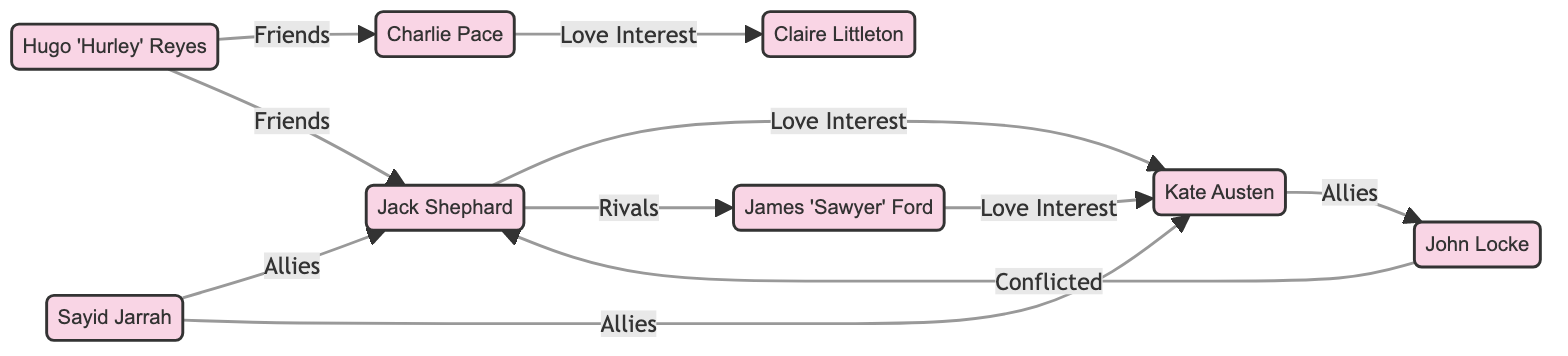What is the relationship between Jack Shephard and Kate Austen? The diagram shows an edge labeled "Love Interest" connecting Jack Shephard to Kate Austen. This indicates that their relationship is characterized as a romantic interest.
Answer: Love Interest How many characters are in the diagram? The diagram lists a total of 8 characters: Jack Shephard, Kate Austen, Sawyer, John Locke, Sayid Jarrah, Hurley, Claire Littleton, and Charlie Pace. Counting these nodes gives us 8 characters.
Answer: 8 Which character is both an ally to Jack Shephard and Kate Austen? To determine this, I can look for characters that have edges labeled "Allies" connecting to both Jack Shephard and Kate Austen. Sayid Jarrah is connected to both with "Allies" edges.
Answer: Sayid Jarrah What do Sawyer and Jack Shephard have in common in the diagram? The diagram shows an edge labeled "Rivals" connecting Jack Shephard to Sawyer, indicating their relationship is antagonistic. This suggests competition or conflict between them.
Answer: Rivals How many edges represent friendships in the diagram? By examining the edges, I count that there are 2 edges labeled "Friends" which connect Hurley to Charlie Pace and Hurley to Jack Shephard.
Answer: 2 Who is Claire Littleton's love interest? The diagram shows an edge from Charlie Pace to Claire Littleton labeled "Love Interest," indicating that Claire's romantic interest is Charlie Pace.
Answer: Charlie Pace What type of relationship does John Locke have with Jack Shephard? The diagram indicates that John Locke is connected to Jack Shephard with a labeled edge "Conflicted," showing their relationship is one of tension and disagreement.
Answer: Conflicted Which character is connected to both Jack Shephard and Kate Austen as an ally? The diagram shows Sayid Jarrah as having edges labeled "Allies" connecting him to both Jack Shephard and Kate Austen, thus he is the character who is allied with both.
Answer: Sayid Jarrah 